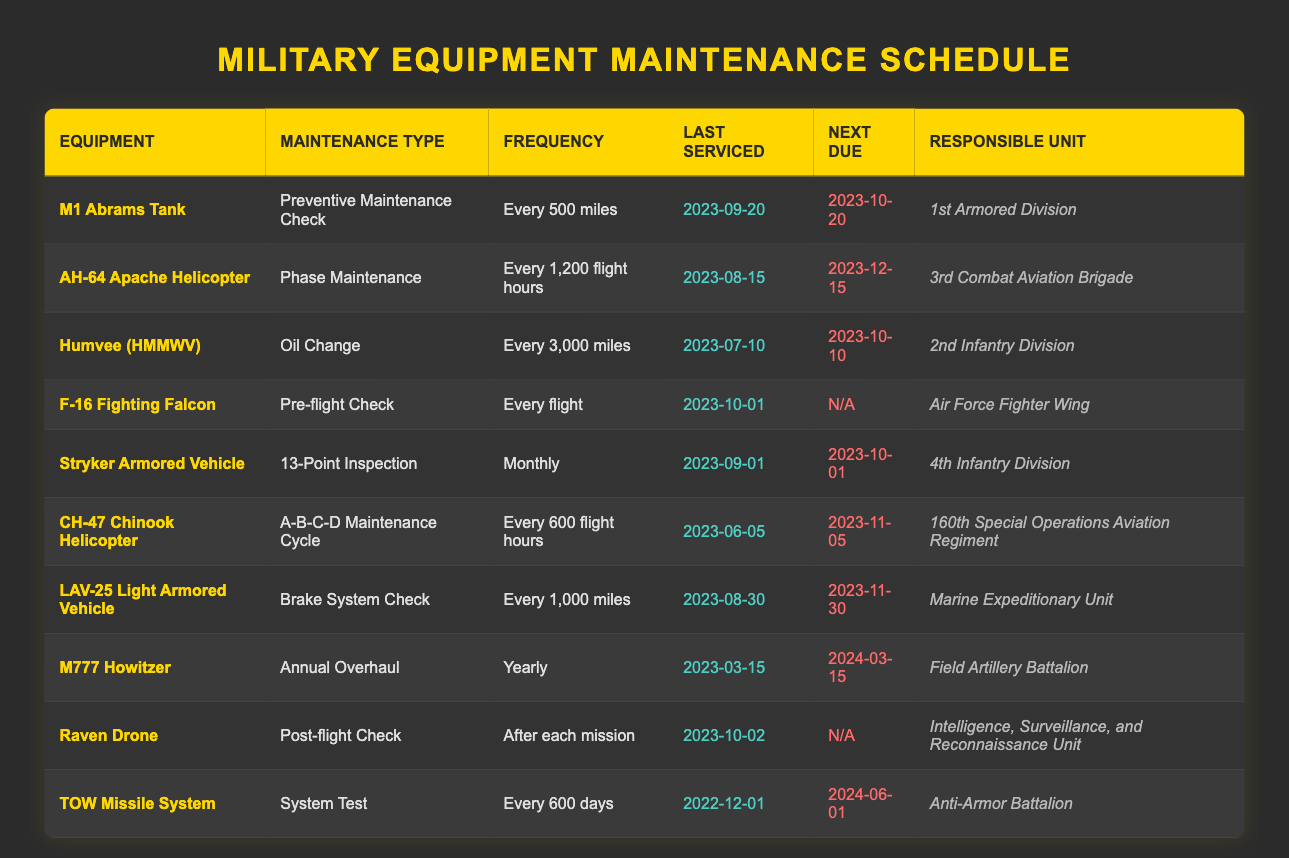What is the maintenance type for the M1 Abrams Tank? The maintenance type for the M1 Abrams Tank is found in the second column of the row corresponding to the M1 Abrams Tank. According to the table, it is "Preventive Maintenance Check."
Answer: Preventive Maintenance Check When is the next due maintenance for the Humvee (HMMWV)? To find the next due maintenance for the Humvee (HMMWV), we look at the corresponding row in the table. The "Next Due" date is listed in the fifth column for this equipment, which states "2023-10-10."
Answer: 2023-10-10 How often does the CH-47 Chinook Helicopter need maintenance? The frequency of maintenance for the CH-47 Chinook Helicopter is specified in the third column of its row. It states that maintenance is required "Every 600 flight hours."
Answer: Every 600 flight hours Has the M777 Howitzer been serviced in the last year? To determine this, we look at the "Last Serviced" date in the M777 Howitzer's row, which shows "2023-03-15." Given today's date is assumed to be after March 15, 2023, this indicates the equipment has been serviced within the last year.
Answer: Yes Which equipment has the longest interval until its next maintenance? To find out which equipment has the longest interval, we need to compare the "Next Due" dates and calculate the days remaining after today. The TOW Missile System is due next on "2024-06-01" while others have earlier dates, indicating it has the longest interval until maintenance.
Answer: TOW Missile System What is the total number of maintenance types listed for ground vehicles only? We identify the ground vehicles in the table, which include the M1 Abrams Tank, Humvee (HMMWV), Stryker Armored Vehicle, and LAV-25 Light Armored Vehicle. The maintenance types for these vehicles are 1 for each vehicle, so there are four distinct maintenance types overall. Thus, the total is 4.
Answer: 4 Is the next due maintenance for the AH-64 Apache Helicopter before the next due for the M1 Abrams Tank? We look at the "Next Due" dates for both the AH-64 Apache Helicopter, which is "2023-12-15," and the M1 Abrams Tank, which is "2023-10-20." Since 2023-10-20 comes before 2023-12-15, the M1 Abrams Tank's maintenance is due first.
Answer: No How many units are responsible for maintenance checks every month? By examining the frequency column, we can count the units that specify monthly maintenance, such as the Stryker Armored Vehicle, which is the only unit listed with "Monthly" maintenance frequency. Therefore, the count is 1.
Answer: 1 What is the difference in service date between the last maintenance of the Raven Drone and the TOW Missile System? To calculate the difference in service dates, we note that the Raven Drone was last serviced on "2023-10-02," and the TOW Missile System on "2022-12-01." Calculating the difference in days gives roughly 304 days between the two.
Answer: 304 days Which maintenance schedule requires the most frequent action? By reviewing each equipment and their designated maintenance frequency, we see the F-16 Fighting Falcon requires action "Every flight," which is more frequent than any other entries in the table.
Answer: F-16 Fighting Falcon 